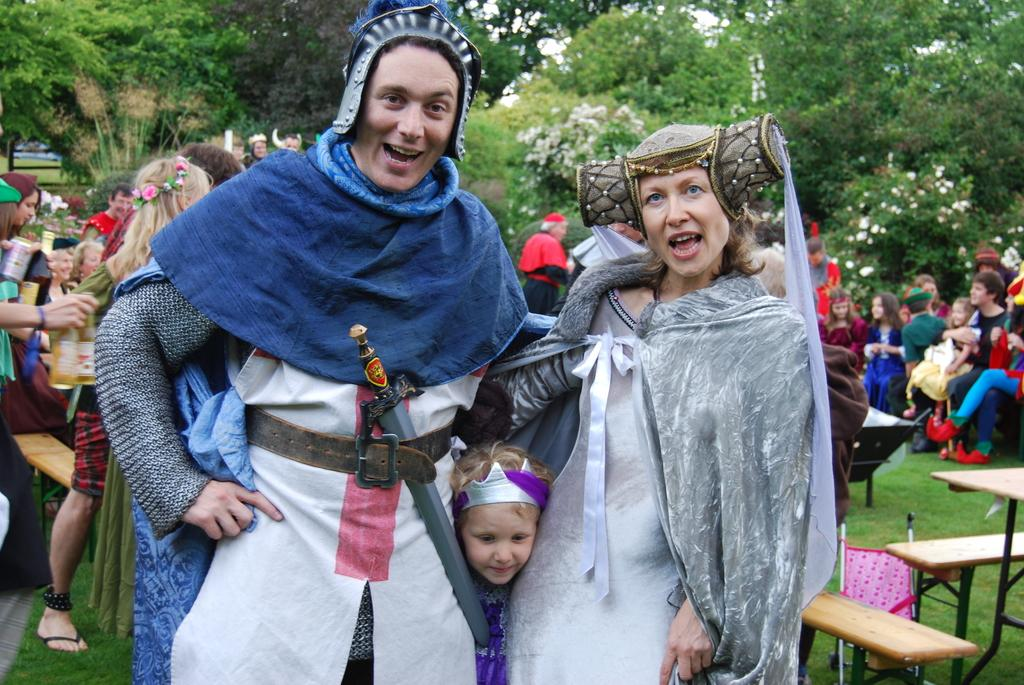How many people are present in the image? There are three people in the image: a man, a woman, and a girl. What are the people in the image wearing? The man, woman, and girl are wearing costumes. What can be seen in the background of the image? There is a group of people, a tree, and flowers visible in the background of the image. What are the people in the background doing? Some of the people in the background are standing, and some are sitting in chairs. What type of crayon is the man using to draw on the woman's costume in the image? There is no crayon present in the image, and the man is not drawing on the woman's costume. What disease is the girl in the image suffering from? There is no indication of any disease in the image, and the girl's health is not mentioned. 